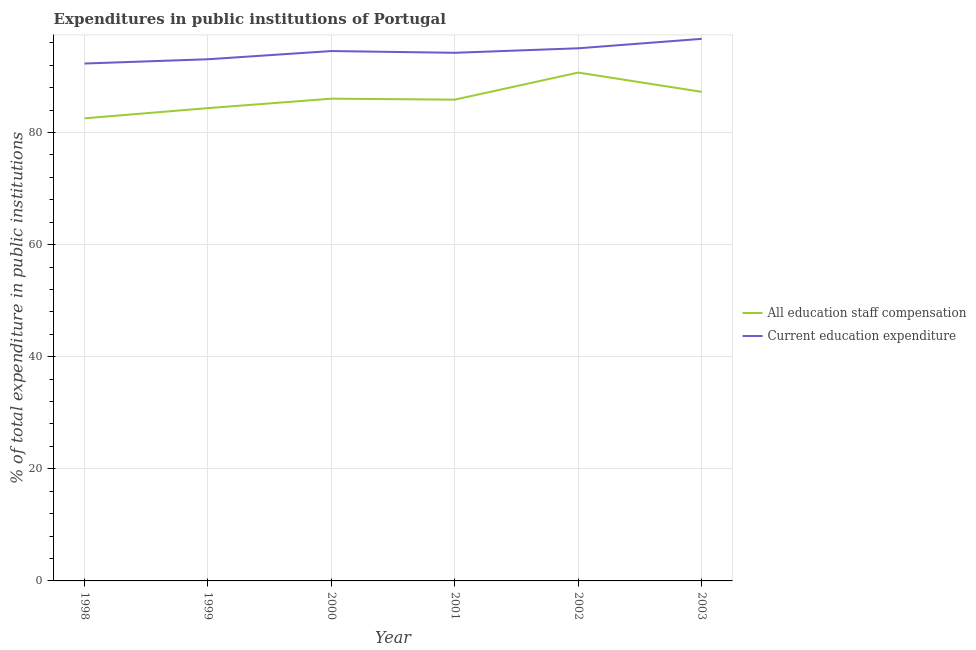Does the line corresponding to expenditure in education intersect with the line corresponding to expenditure in staff compensation?
Provide a short and direct response. No. What is the expenditure in education in 1999?
Offer a very short reply. 93.07. Across all years, what is the maximum expenditure in education?
Provide a succinct answer. 96.71. Across all years, what is the minimum expenditure in education?
Offer a terse response. 92.31. In which year was the expenditure in education maximum?
Ensure brevity in your answer.  2003. What is the total expenditure in education in the graph?
Give a very brief answer. 565.87. What is the difference between the expenditure in staff compensation in 1999 and that in 2002?
Keep it short and to the point. -6.34. What is the difference between the expenditure in staff compensation in 2003 and the expenditure in education in 2001?
Your answer should be compact. -6.96. What is the average expenditure in education per year?
Your answer should be compact. 94.31. In the year 2000, what is the difference between the expenditure in staff compensation and expenditure in education?
Provide a succinct answer. -8.5. In how many years, is the expenditure in education greater than 84 %?
Your answer should be compact. 6. What is the ratio of the expenditure in staff compensation in 1998 to that in 2001?
Make the answer very short. 0.96. Is the expenditure in education in 1999 less than that in 2002?
Your response must be concise. Yes. What is the difference between the highest and the second highest expenditure in education?
Ensure brevity in your answer.  1.68. What is the difference between the highest and the lowest expenditure in staff compensation?
Provide a short and direct response. 8.16. In how many years, is the expenditure in staff compensation greater than the average expenditure in staff compensation taken over all years?
Offer a very short reply. 2. Does the expenditure in staff compensation monotonically increase over the years?
Keep it short and to the point. No. Is the expenditure in education strictly greater than the expenditure in staff compensation over the years?
Your response must be concise. Yes. Is the expenditure in staff compensation strictly less than the expenditure in education over the years?
Your answer should be very brief. Yes. How many lines are there?
Keep it short and to the point. 2. How many years are there in the graph?
Offer a very short reply. 6. What is the difference between two consecutive major ticks on the Y-axis?
Provide a succinct answer. 20. Does the graph contain grids?
Offer a very short reply. Yes. How are the legend labels stacked?
Provide a short and direct response. Vertical. What is the title of the graph?
Make the answer very short. Expenditures in public institutions of Portugal. Does "Enforce a contract" appear as one of the legend labels in the graph?
Your answer should be very brief. No. What is the label or title of the X-axis?
Your response must be concise. Year. What is the label or title of the Y-axis?
Provide a short and direct response. % of total expenditure in public institutions. What is the % of total expenditure in public institutions of All education staff compensation in 1998?
Offer a terse response. 82.53. What is the % of total expenditure in public institutions of Current education expenditure in 1998?
Give a very brief answer. 92.31. What is the % of total expenditure in public institutions of All education staff compensation in 1999?
Keep it short and to the point. 84.36. What is the % of total expenditure in public institutions in Current education expenditure in 1999?
Your answer should be compact. 93.07. What is the % of total expenditure in public institutions of All education staff compensation in 2000?
Your answer should be compact. 86.04. What is the % of total expenditure in public institutions of Current education expenditure in 2000?
Give a very brief answer. 94.54. What is the % of total expenditure in public institutions of All education staff compensation in 2001?
Make the answer very short. 85.87. What is the % of total expenditure in public institutions of Current education expenditure in 2001?
Make the answer very short. 94.22. What is the % of total expenditure in public institutions of All education staff compensation in 2002?
Keep it short and to the point. 90.69. What is the % of total expenditure in public institutions of Current education expenditure in 2002?
Your answer should be very brief. 95.03. What is the % of total expenditure in public institutions of All education staff compensation in 2003?
Offer a terse response. 87.26. What is the % of total expenditure in public institutions in Current education expenditure in 2003?
Provide a succinct answer. 96.71. Across all years, what is the maximum % of total expenditure in public institutions in All education staff compensation?
Provide a succinct answer. 90.69. Across all years, what is the maximum % of total expenditure in public institutions of Current education expenditure?
Make the answer very short. 96.71. Across all years, what is the minimum % of total expenditure in public institutions of All education staff compensation?
Provide a succinct answer. 82.53. Across all years, what is the minimum % of total expenditure in public institutions in Current education expenditure?
Offer a terse response. 92.31. What is the total % of total expenditure in public institutions in All education staff compensation in the graph?
Offer a terse response. 516.74. What is the total % of total expenditure in public institutions of Current education expenditure in the graph?
Make the answer very short. 565.87. What is the difference between the % of total expenditure in public institutions in All education staff compensation in 1998 and that in 1999?
Provide a short and direct response. -1.82. What is the difference between the % of total expenditure in public institutions in Current education expenditure in 1998 and that in 1999?
Your answer should be compact. -0.76. What is the difference between the % of total expenditure in public institutions of All education staff compensation in 1998 and that in 2000?
Your answer should be very brief. -3.5. What is the difference between the % of total expenditure in public institutions in Current education expenditure in 1998 and that in 2000?
Ensure brevity in your answer.  -2.23. What is the difference between the % of total expenditure in public institutions in All education staff compensation in 1998 and that in 2001?
Keep it short and to the point. -3.33. What is the difference between the % of total expenditure in public institutions of Current education expenditure in 1998 and that in 2001?
Give a very brief answer. -1.91. What is the difference between the % of total expenditure in public institutions in All education staff compensation in 1998 and that in 2002?
Offer a very short reply. -8.16. What is the difference between the % of total expenditure in public institutions of Current education expenditure in 1998 and that in 2002?
Give a very brief answer. -2.72. What is the difference between the % of total expenditure in public institutions of All education staff compensation in 1998 and that in 2003?
Your response must be concise. -4.72. What is the difference between the % of total expenditure in public institutions of Current education expenditure in 1998 and that in 2003?
Provide a succinct answer. -4.4. What is the difference between the % of total expenditure in public institutions of All education staff compensation in 1999 and that in 2000?
Provide a short and direct response. -1.68. What is the difference between the % of total expenditure in public institutions of Current education expenditure in 1999 and that in 2000?
Offer a terse response. -1.46. What is the difference between the % of total expenditure in public institutions in All education staff compensation in 1999 and that in 2001?
Offer a very short reply. -1.51. What is the difference between the % of total expenditure in public institutions in Current education expenditure in 1999 and that in 2001?
Offer a very short reply. -1.15. What is the difference between the % of total expenditure in public institutions in All education staff compensation in 1999 and that in 2002?
Give a very brief answer. -6.34. What is the difference between the % of total expenditure in public institutions in Current education expenditure in 1999 and that in 2002?
Your answer should be very brief. -1.96. What is the difference between the % of total expenditure in public institutions of All education staff compensation in 1999 and that in 2003?
Offer a very short reply. -2.9. What is the difference between the % of total expenditure in public institutions in Current education expenditure in 1999 and that in 2003?
Provide a succinct answer. -3.64. What is the difference between the % of total expenditure in public institutions of All education staff compensation in 2000 and that in 2001?
Offer a terse response. 0.17. What is the difference between the % of total expenditure in public institutions in Current education expenditure in 2000 and that in 2001?
Provide a succinct answer. 0.31. What is the difference between the % of total expenditure in public institutions in All education staff compensation in 2000 and that in 2002?
Your answer should be compact. -4.66. What is the difference between the % of total expenditure in public institutions in Current education expenditure in 2000 and that in 2002?
Offer a terse response. -0.49. What is the difference between the % of total expenditure in public institutions in All education staff compensation in 2000 and that in 2003?
Give a very brief answer. -1.22. What is the difference between the % of total expenditure in public institutions in Current education expenditure in 2000 and that in 2003?
Provide a short and direct response. -2.18. What is the difference between the % of total expenditure in public institutions of All education staff compensation in 2001 and that in 2002?
Provide a succinct answer. -4.83. What is the difference between the % of total expenditure in public institutions in Current education expenditure in 2001 and that in 2002?
Your response must be concise. -0.8. What is the difference between the % of total expenditure in public institutions of All education staff compensation in 2001 and that in 2003?
Keep it short and to the point. -1.39. What is the difference between the % of total expenditure in public institutions in Current education expenditure in 2001 and that in 2003?
Provide a succinct answer. -2.49. What is the difference between the % of total expenditure in public institutions in All education staff compensation in 2002 and that in 2003?
Your answer should be compact. 3.44. What is the difference between the % of total expenditure in public institutions in Current education expenditure in 2002 and that in 2003?
Your answer should be compact. -1.68. What is the difference between the % of total expenditure in public institutions in All education staff compensation in 1998 and the % of total expenditure in public institutions in Current education expenditure in 1999?
Make the answer very short. -10.54. What is the difference between the % of total expenditure in public institutions of All education staff compensation in 1998 and the % of total expenditure in public institutions of Current education expenditure in 2000?
Your response must be concise. -12. What is the difference between the % of total expenditure in public institutions in All education staff compensation in 1998 and the % of total expenditure in public institutions in Current education expenditure in 2001?
Your response must be concise. -11.69. What is the difference between the % of total expenditure in public institutions of All education staff compensation in 1998 and the % of total expenditure in public institutions of Current education expenditure in 2002?
Ensure brevity in your answer.  -12.49. What is the difference between the % of total expenditure in public institutions in All education staff compensation in 1998 and the % of total expenditure in public institutions in Current education expenditure in 2003?
Your answer should be very brief. -14.18. What is the difference between the % of total expenditure in public institutions of All education staff compensation in 1999 and the % of total expenditure in public institutions of Current education expenditure in 2000?
Your answer should be compact. -10.18. What is the difference between the % of total expenditure in public institutions in All education staff compensation in 1999 and the % of total expenditure in public institutions in Current education expenditure in 2001?
Your answer should be compact. -9.87. What is the difference between the % of total expenditure in public institutions of All education staff compensation in 1999 and the % of total expenditure in public institutions of Current education expenditure in 2002?
Offer a very short reply. -10.67. What is the difference between the % of total expenditure in public institutions in All education staff compensation in 1999 and the % of total expenditure in public institutions in Current education expenditure in 2003?
Keep it short and to the point. -12.36. What is the difference between the % of total expenditure in public institutions of All education staff compensation in 2000 and the % of total expenditure in public institutions of Current education expenditure in 2001?
Make the answer very short. -8.19. What is the difference between the % of total expenditure in public institutions of All education staff compensation in 2000 and the % of total expenditure in public institutions of Current education expenditure in 2002?
Your response must be concise. -8.99. What is the difference between the % of total expenditure in public institutions in All education staff compensation in 2000 and the % of total expenditure in public institutions in Current education expenditure in 2003?
Provide a short and direct response. -10.67. What is the difference between the % of total expenditure in public institutions in All education staff compensation in 2001 and the % of total expenditure in public institutions in Current education expenditure in 2002?
Provide a succinct answer. -9.16. What is the difference between the % of total expenditure in public institutions in All education staff compensation in 2001 and the % of total expenditure in public institutions in Current education expenditure in 2003?
Keep it short and to the point. -10.85. What is the difference between the % of total expenditure in public institutions of All education staff compensation in 2002 and the % of total expenditure in public institutions of Current education expenditure in 2003?
Make the answer very short. -6.02. What is the average % of total expenditure in public institutions in All education staff compensation per year?
Provide a short and direct response. 86.12. What is the average % of total expenditure in public institutions in Current education expenditure per year?
Give a very brief answer. 94.31. In the year 1998, what is the difference between the % of total expenditure in public institutions of All education staff compensation and % of total expenditure in public institutions of Current education expenditure?
Your response must be concise. -9.77. In the year 1999, what is the difference between the % of total expenditure in public institutions of All education staff compensation and % of total expenditure in public institutions of Current education expenditure?
Keep it short and to the point. -8.72. In the year 2000, what is the difference between the % of total expenditure in public institutions of All education staff compensation and % of total expenditure in public institutions of Current education expenditure?
Your answer should be very brief. -8.5. In the year 2001, what is the difference between the % of total expenditure in public institutions of All education staff compensation and % of total expenditure in public institutions of Current education expenditure?
Provide a short and direct response. -8.36. In the year 2002, what is the difference between the % of total expenditure in public institutions of All education staff compensation and % of total expenditure in public institutions of Current education expenditure?
Your answer should be compact. -4.33. In the year 2003, what is the difference between the % of total expenditure in public institutions of All education staff compensation and % of total expenditure in public institutions of Current education expenditure?
Give a very brief answer. -9.45. What is the ratio of the % of total expenditure in public institutions of All education staff compensation in 1998 to that in 1999?
Provide a succinct answer. 0.98. What is the ratio of the % of total expenditure in public institutions in All education staff compensation in 1998 to that in 2000?
Provide a succinct answer. 0.96. What is the ratio of the % of total expenditure in public institutions in Current education expenditure in 1998 to that in 2000?
Keep it short and to the point. 0.98. What is the ratio of the % of total expenditure in public institutions of All education staff compensation in 1998 to that in 2001?
Ensure brevity in your answer.  0.96. What is the ratio of the % of total expenditure in public institutions in Current education expenditure in 1998 to that in 2001?
Ensure brevity in your answer.  0.98. What is the ratio of the % of total expenditure in public institutions in All education staff compensation in 1998 to that in 2002?
Your response must be concise. 0.91. What is the ratio of the % of total expenditure in public institutions in Current education expenditure in 1998 to that in 2002?
Your response must be concise. 0.97. What is the ratio of the % of total expenditure in public institutions of All education staff compensation in 1998 to that in 2003?
Your answer should be compact. 0.95. What is the ratio of the % of total expenditure in public institutions in Current education expenditure in 1998 to that in 2003?
Your answer should be compact. 0.95. What is the ratio of the % of total expenditure in public institutions in All education staff compensation in 1999 to that in 2000?
Make the answer very short. 0.98. What is the ratio of the % of total expenditure in public institutions in Current education expenditure in 1999 to that in 2000?
Your response must be concise. 0.98. What is the ratio of the % of total expenditure in public institutions in All education staff compensation in 1999 to that in 2001?
Provide a succinct answer. 0.98. What is the ratio of the % of total expenditure in public institutions of All education staff compensation in 1999 to that in 2002?
Offer a terse response. 0.93. What is the ratio of the % of total expenditure in public institutions in Current education expenditure in 1999 to that in 2002?
Offer a terse response. 0.98. What is the ratio of the % of total expenditure in public institutions of All education staff compensation in 1999 to that in 2003?
Offer a very short reply. 0.97. What is the ratio of the % of total expenditure in public institutions of Current education expenditure in 1999 to that in 2003?
Offer a very short reply. 0.96. What is the ratio of the % of total expenditure in public institutions of All education staff compensation in 2000 to that in 2002?
Provide a short and direct response. 0.95. What is the ratio of the % of total expenditure in public institutions in Current education expenditure in 2000 to that in 2003?
Offer a terse response. 0.98. What is the ratio of the % of total expenditure in public institutions in All education staff compensation in 2001 to that in 2002?
Provide a short and direct response. 0.95. What is the ratio of the % of total expenditure in public institutions in Current education expenditure in 2001 to that in 2002?
Make the answer very short. 0.99. What is the ratio of the % of total expenditure in public institutions in Current education expenditure in 2001 to that in 2003?
Give a very brief answer. 0.97. What is the ratio of the % of total expenditure in public institutions of All education staff compensation in 2002 to that in 2003?
Give a very brief answer. 1.04. What is the ratio of the % of total expenditure in public institutions of Current education expenditure in 2002 to that in 2003?
Offer a terse response. 0.98. What is the difference between the highest and the second highest % of total expenditure in public institutions of All education staff compensation?
Your answer should be compact. 3.44. What is the difference between the highest and the second highest % of total expenditure in public institutions in Current education expenditure?
Give a very brief answer. 1.68. What is the difference between the highest and the lowest % of total expenditure in public institutions in All education staff compensation?
Your response must be concise. 8.16. What is the difference between the highest and the lowest % of total expenditure in public institutions in Current education expenditure?
Make the answer very short. 4.4. 